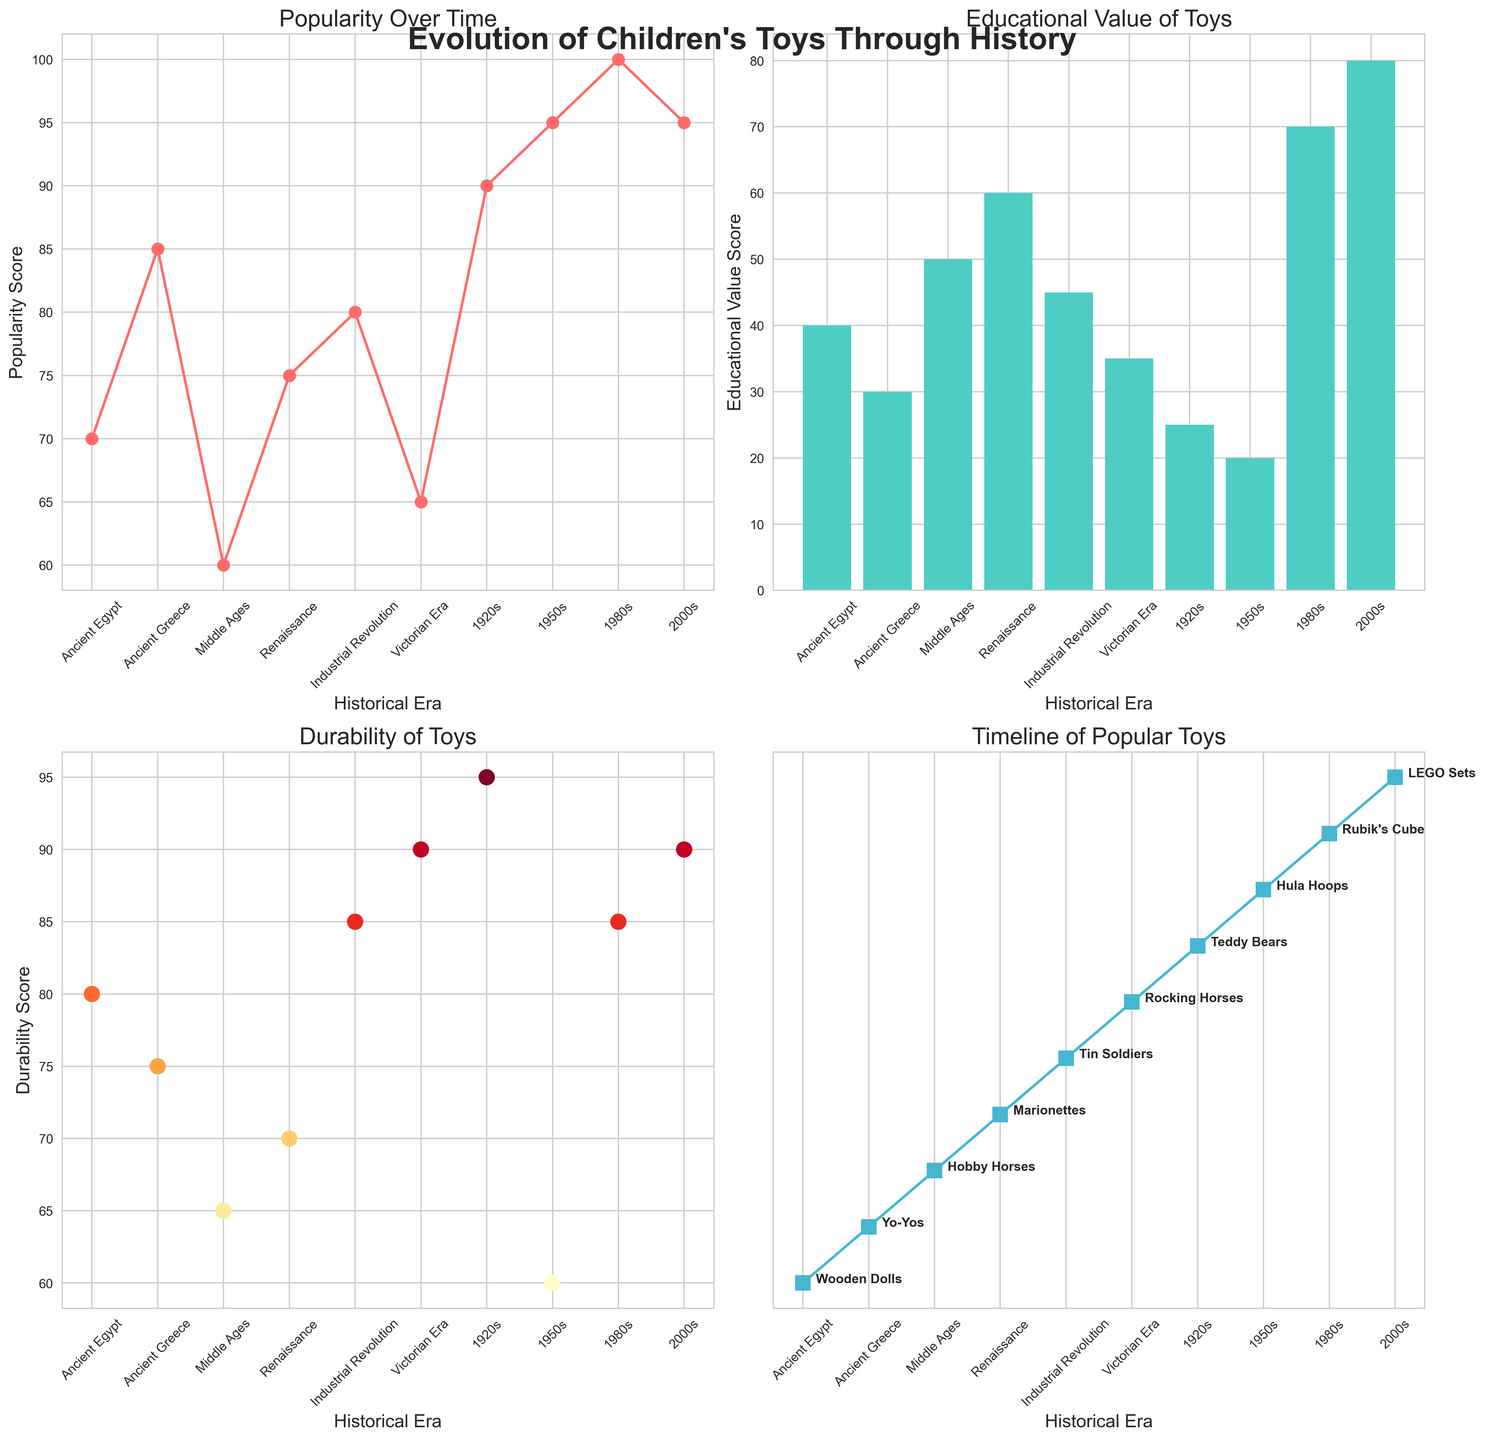What's the title of the entire figure? The title of the figure is located at the top center of the figure. It reads "Evolution of Children's Toys Through History" in bold, large font.
Answer: Evolution of Children's Toys Through History Which toy era shows the highest popularity according to the plot? To find the era with the highest popularity, look at the "Popularity Over Time" plot in the top-left subplot. The highest point on the y-axis corresponds to the 1980s with a popularity score of 100.
Answer: 1980s Which toy has the highest educational value and in which era does it belong? Examine the bar chart in the top-right subplot titled "Educational Value of Toys." The tallest bar, indicating the highest educational value, corresponds to LEGO Sets from the 2000s with a score of 80.
Answer: LEGO Sets, 2000s What's the durability score of the toy from the Industrial Revolution era? Refer to the scatter plot in the bottom-left subplot titled "Durability of Toys." Locate the era "Industrial Revolution" on the x-axis and read the corresponding y-axis value. The durability score for Tin Soldiers is 85.
Answer: 85 Compare the educational value scores of toys from the Middle Ages and the Industrial Revolution. Which one is higher, and by how much? Look at the bar chart in the top-right subplot. The educational value for Middle Ages (Hobby Horses) is 50, while for the Industrial Revolution (Tin Soldiers), it is 45. Subtract 45 from 50 to find the difference.
Answer: Middle Ages, by 5 Which toy has the highest durability score and which toy era does it belong to? Check the scatter plot in the bottom-left subplot for the point highest on the y-axis. The highest durability score of 95 belongs to Teddy Bears from the 1920s.
Answer: Teddy Bears, 1920s At which era did the popularity score sharply increase from the preceding era? Observe the line plot in the top-left subplot and look for a steep incline. Notice the increase from the Renaissance (75) to the Industrial Revolution (80) isn't as sharp. However, there is a sharper increase from the Victorian Era (65) to the 1920s (90).
Answer: 1920s Which two toys have the lowest educational value scores and how are they represented in the figure? Look at the bar chart in the top-right subplot. The two shortest bars correspond to Hula Hoops (1950s) and Teddy Bears (1920s) with educational values of 20 and 25, respectively.
Answer: Hula Hoops, Teddy Bears What's the trend in the durability of toys from the Middle Ages to the 2000s? Inspect the scatter plot in the bottom-left subplot and follow the sequence from the Middle Ages to the 2000s. There is an overall increasing trend in durability scores from 65 (Middle Ages) to 70 (Renaissance), 85 (Industrial Revolution), 90 (Victorian Era), decreasing to 60 (1950s), and increasing again to 90 (2000s).
Answer: Increasing trend List all the toys that have maintained the highest popularity score over different eras. Refer to the line plot in the top-left subplot. The highest score of 100 is maintained by Rubik's Cube in the 1980s. Additionally, note the 95 score maintained by both Hula Hoops (1950s) and LEGO Sets (2000s).
Answer: Rubik's Cube 